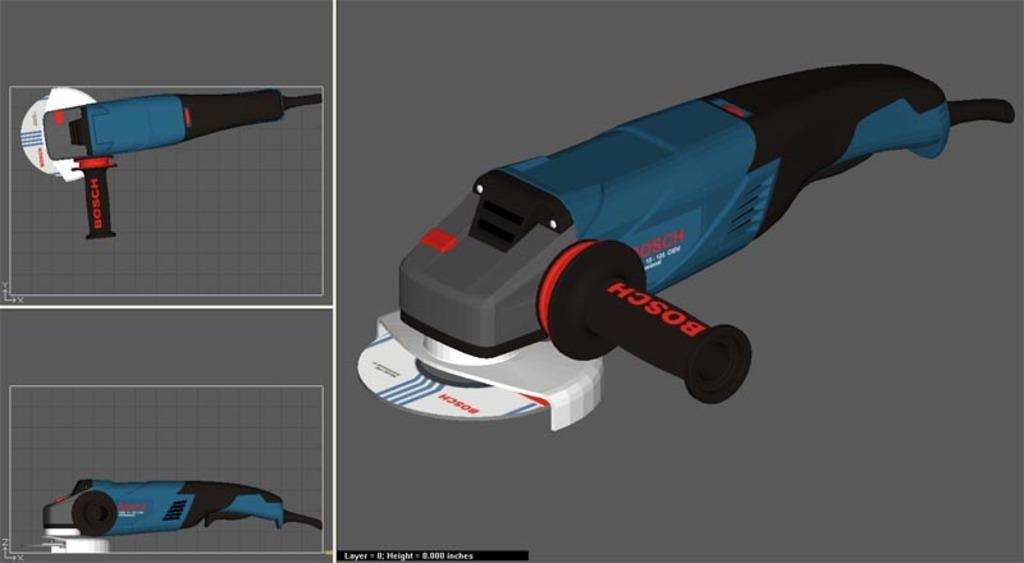What type of machine is in the image? There is a cutting machine in the image. What color is the cutting machine? The cutting machine is blue in color. Where is the stomach of the cutting machine located in the image? The cutting machine does not have a stomach, as it is a machine and not a living organism. Can you tell me how many items are in the pocket of the cutting machine in the image? The cutting machine does not have pockets, as it is a machine and not a piece of clothing. 